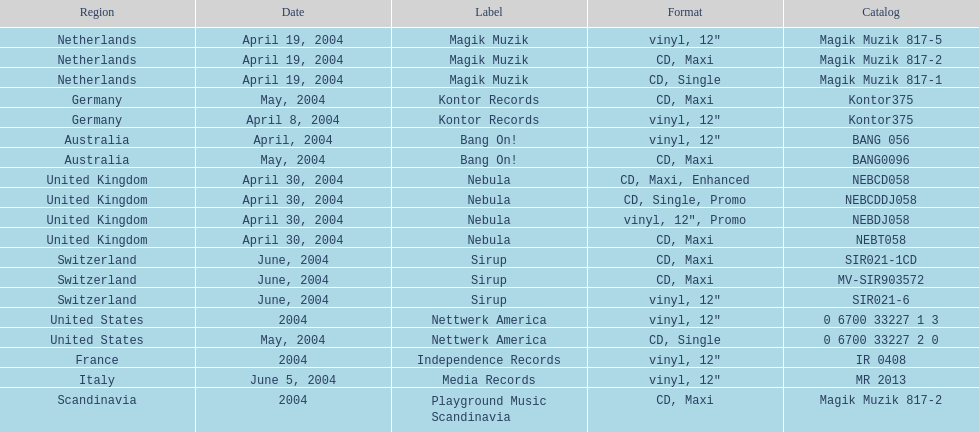What designation was italy under? Media Records. 